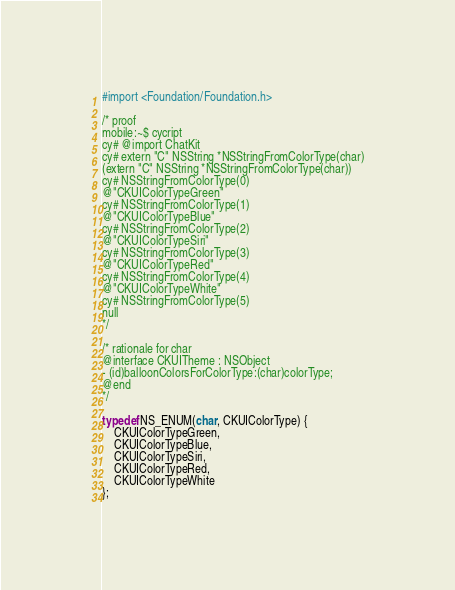Convert code to text. <code><loc_0><loc_0><loc_500><loc_500><_C_>#import <Foundation/Foundation.h>

/* proof
mobile:~$ cycript 
cy# @import ChatKit
cy# extern "C" NSString *NSStringFromColorType(char)
(extern "C" NSString *NSStringFromColorType(char))
cy# NSStringFromColorType(0)
@"CKUIColorTypeGreen"
cy# NSStringFromColorType(1)
@"CKUIColorTypeBlue"
cy# NSStringFromColorType(2)
@"CKUIColorTypeSiri"
cy# NSStringFromColorType(3)
@"CKUIColorTypeRed"
cy# NSStringFromColorType(4)
@"CKUIColorTypeWhite"
cy# NSStringFromColorType(5)
null
*/

/* rationale for char
@interface CKUITheme : NSObject
- (id)balloonColorsForColorType:(char)colorType;
@end
*/

typedef NS_ENUM(char, CKUIColorType) {
    CKUIColorTypeGreen,
    CKUIColorTypeBlue,
    CKUIColorTypeSiri,
    CKUIColorTypeRed,
    CKUIColorTypeWhite
};
</code> 